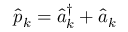Convert formula to latex. <formula><loc_0><loc_0><loc_500><loc_500>\hat { p } _ { k } = \hat { a } _ { k } ^ { \dagger } + \hat { a } _ { k }</formula> 